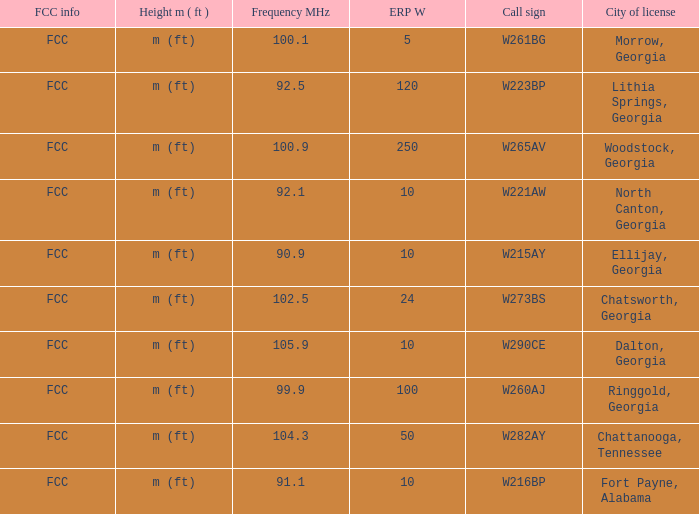What is the number of Frequency MHz in woodstock, georgia? 100.9. 